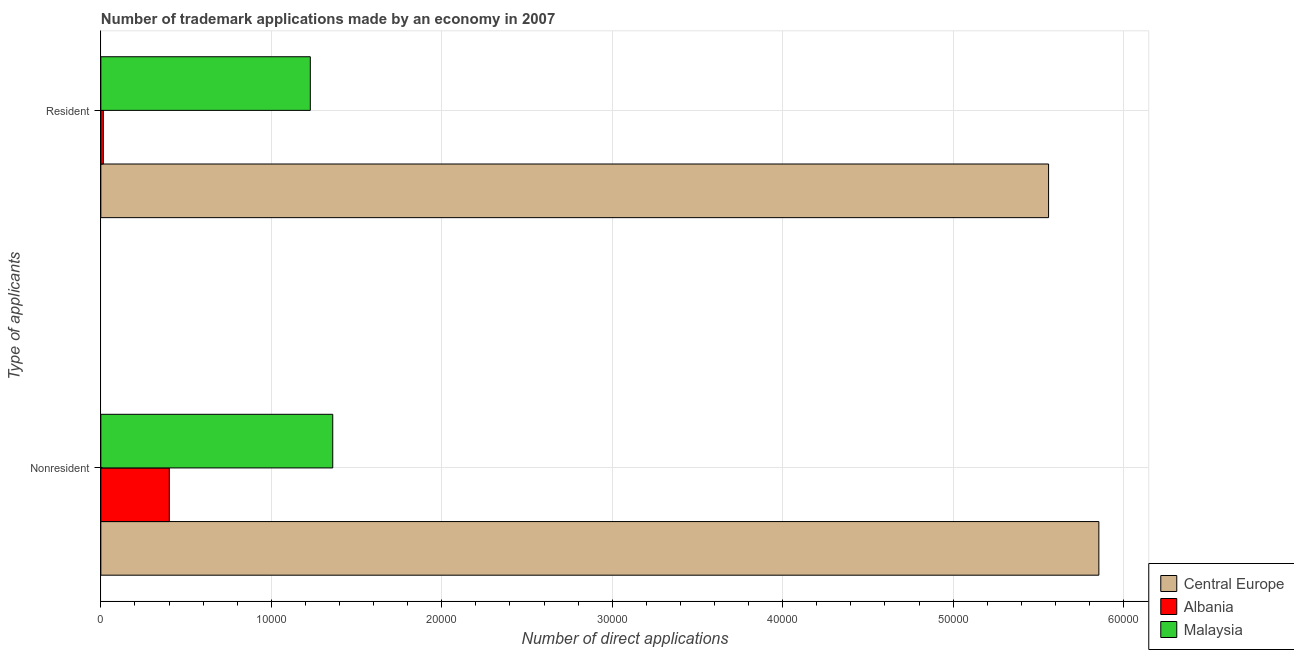How many different coloured bars are there?
Keep it short and to the point. 3. How many groups of bars are there?
Provide a succinct answer. 2. What is the label of the 2nd group of bars from the top?
Provide a succinct answer. Nonresident. What is the number of trademark applications made by residents in Malaysia?
Offer a very short reply. 1.23e+04. Across all countries, what is the maximum number of trademark applications made by non residents?
Make the answer very short. 5.85e+04. Across all countries, what is the minimum number of trademark applications made by residents?
Ensure brevity in your answer.  148. In which country was the number of trademark applications made by non residents maximum?
Offer a very short reply. Central Europe. In which country was the number of trademark applications made by non residents minimum?
Keep it short and to the point. Albania. What is the total number of trademark applications made by residents in the graph?
Your answer should be very brief. 6.80e+04. What is the difference between the number of trademark applications made by non residents in Albania and that in Malaysia?
Your answer should be compact. -9590. What is the difference between the number of trademark applications made by non residents in Malaysia and the number of trademark applications made by residents in Central Europe?
Offer a terse response. -4.20e+04. What is the average number of trademark applications made by residents per country?
Ensure brevity in your answer.  2.27e+04. What is the difference between the number of trademark applications made by non residents and number of trademark applications made by residents in Albania?
Provide a succinct answer. 3867. In how many countries, is the number of trademark applications made by residents greater than 36000 ?
Make the answer very short. 1. What is the ratio of the number of trademark applications made by non residents in Malaysia to that in Central Europe?
Provide a succinct answer. 0.23. What does the 3rd bar from the top in Nonresident represents?
Your answer should be compact. Central Europe. What does the 3rd bar from the bottom in Nonresident represents?
Offer a very short reply. Malaysia. How many bars are there?
Your answer should be compact. 6. Are the values on the major ticks of X-axis written in scientific E-notation?
Offer a very short reply. No. Does the graph contain any zero values?
Make the answer very short. No. Does the graph contain grids?
Your answer should be very brief. Yes. How many legend labels are there?
Offer a terse response. 3. What is the title of the graph?
Your response must be concise. Number of trademark applications made by an economy in 2007. Does "High income: nonOECD" appear as one of the legend labels in the graph?
Give a very brief answer. No. What is the label or title of the X-axis?
Provide a short and direct response. Number of direct applications. What is the label or title of the Y-axis?
Your response must be concise. Type of applicants. What is the Number of direct applications in Central Europe in Nonresident?
Your answer should be compact. 5.85e+04. What is the Number of direct applications of Albania in Nonresident?
Keep it short and to the point. 4015. What is the Number of direct applications of Malaysia in Nonresident?
Your answer should be very brief. 1.36e+04. What is the Number of direct applications of Central Europe in Resident?
Provide a short and direct response. 5.56e+04. What is the Number of direct applications of Albania in Resident?
Offer a terse response. 148. What is the Number of direct applications in Malaysia in Resident?
Your answer should be very brief. 1.23e+04. Across all Type of applicants, what is the maximum Number of direct applications in Central Europe?
Your response must be concise. 5.85e+04. Across all Type of applicants, what is the maximum Number of direct applications of Albania?
Your answer should be very brief. 4015. Across all Type of applicants, what is the maximum Number of direct applications in Malaysia?
Offer a very short reply. 1.36e+04. Across all Type of applicants, what is the minimum Number of direct applications in Central Europe?
Your response must be concise. 5.56e+04. Across all Type of applicants, what is the minimum Number of direct applications in Albania?
Give a very brief answer. 148. Across all Type of applicants, what is the minimum Number of direct applications of Malaysia?
Give a very brief answer. 1.23e+04. What is the total Number of direct applications of Central Europe in the graph?
Provide a short and direct response. 1.14e+05. What is the total Number of direct applications in Albania in the graph?
Ensure brevity in your answer.  4163. What is the total Number of direct applications in Malaysia in the graph?
Ensure brevity in your answer.  2.59e+04. What is the difference between the Number of direct applications in Central Europe in Nonresident and that in Resident?
Give a very brief answer. 2950. What is the difference between the Number of direct applications in Albania in Nonresident and that in Resident?
Your response must be concise. 3867. What is the difference between the Number of direct applications in Malaysia in Nonresident and that in Resident?
Offer a terse response. 1316. What is the difference between the Number of direct applications of Central Europe in Nonresident and the Number of direct applications of Albania in Resident?
Provide a succinct answer. 5.84e+04. What is the difference between the Number of direct applications in Central Europe in Nonresident and the Number of direct applications in Malaysia in Resident?
Make the answer very short. 4.63e+04. What is the difference between the Number of direct applications in Albania in Nonresident and the Number of direct applications in Malaysia in Resident?
Offer a terse response. -8274. What is the average Number of direct applications in Central Europe per Type of applicants?
Offer a terse response. 5.71e+04. What is the average Number of direct applications of Albania per Type of applicants?
Your answer should be very brief. 2081.5. What is the average Number of direct applications of Malaysia per Type of applicants?
Your response must be concise. 1.29e+04. What is the difference between the Number of direct applications of Central Europe and Number of direct applications of Albania in Nonresident?
Your answer should be compact. 5.45e+04. What is the difference between the Number of direct applications of Central Europe and Number of direct applications of Malaysia in Nonresident?
Offer a very short reply. 4.49e+04. What is the difference between the Number of direct applications of Albania and Number of direct applications of Malaysia in Nonresident?
Provide a short and direct response. -9590. What is the difference between the Number of direct applications in Central Europe and Number of direct applications in Albania in Resident?
Make the answer very short. 5.55e+04. What is the difference between the Number of direct applications of Central Europe and Number of direct applications of Malaysia in Resident?
Offer a very short reply. 4.33e+04. What is the difference between the Number of direct applications in Albania and Number of direct applications in Malaysia in Resident?
Offer a very short reply. -1.21e+04. What is the ratio of the Number of direct applications of Central Europe in Nonresident to that in Resident?
Offer a very short reply. 1.05. What is the ratio of the Number of direct applications in Albania in Nonresident to that in Resident?
Provide a succinct answer. 27.13. What is the ratio of the Number of direct applications in Malaysia in Nonresident to that in Resident?
Make the answer very short. 1.11. What is the difference between the highest and the second highest Number of direct applications of Central Europe?
Give a very brief answer. 2950. What is the difference between the highest and the second highest Number of direct applications of Albania?
Keep it short and to the point. 3867. What is the difference between the highest and the second highest Number of direct applications of Malaysia?
Provide a short and direct response. 1316. What is the difference between the highest and the lowest Number of direct applications of Central Europe?
Give a very brief answer. 2950. What is the difference between the highest and the lowest Number of direct applications of Albania?
Your answer should be very brief. 3867. What is the difference between the highest and the lowest Number of direct applications of Malaysia?
Offer a terse response. 1316. 